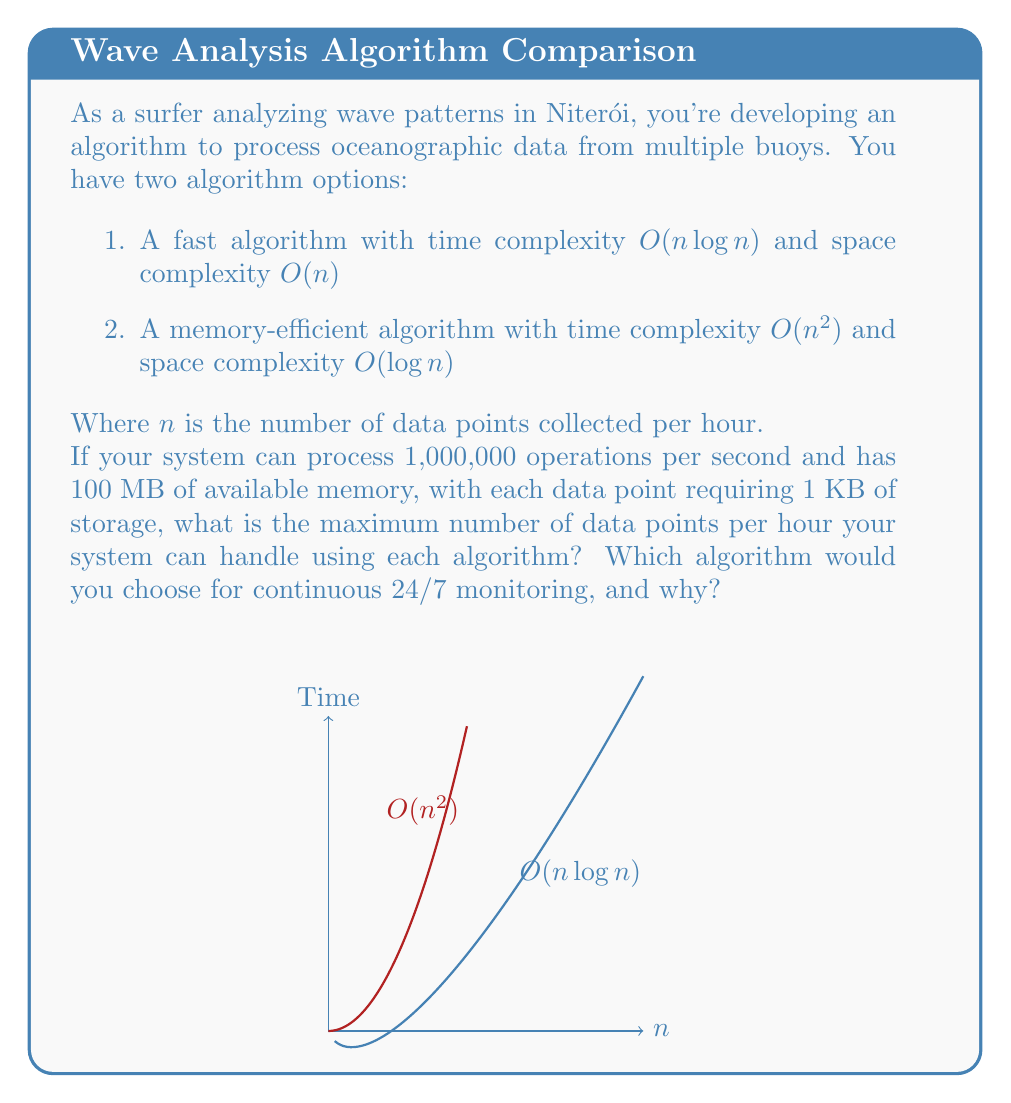Could you help me with this problem? Let's analyze each algorithm:

1. Fast algorithm:
   Time complexity: $O(n \log n)$
   Space complexity: $O(n)$

   Time constraint:
   $n \log_2 n \leq 1,000,000$ (operations per second)
   
   Space constraint:
   $n \cdot 1\text{ KB} \leq 100\text{ MB} = 100,000\text{ KB}$
   $n \leq 100,000$

2. Memory-efficient algorithm:
   Time complexity: $O(n^2)$
   Space complexity: $O(\log n)$

   Time constraint:
   $n^2 \leq 1,000,000$
   $n \leq \sqrt{1,000,000} = 1,000$

   Space constraint:
   $\log_2 n \cdot 1\text{ KB} \leq 100\text{ MB} = 100,000\text{ KB}$
   $\log_2 n \leq 100,000$
   $n \leq 2^{100,000}$ (which is a huge number, not limiting in this case)

For the fast algorithm, the space constraint is more limiting. So, it can handle up to 100,000 data points per hour.

For the memory-efficient algorithm, the time constraint is more limiting. So, it can handle up to 1,000 data points per hour.

For continuous 24/7 monitoring, the fast algorithm would be the better choice because:
1. It can process 100 times more data points per hour.
2. Its time complexity grows more slowly as n increases, making it more scalable.
3. The space requirement, while higher, is still within the system's capabilities.

The memory-efficient algorithm, despite using less space, is too slow for processing large amounts of data continuously.
Answer: Fast algorithm: 100,000 points/hour. Memory-efficient algorithm: 1,000 points/hour. Choose fast algorithm for 24/7 monitoring due to higher data capacity and better scalability. 